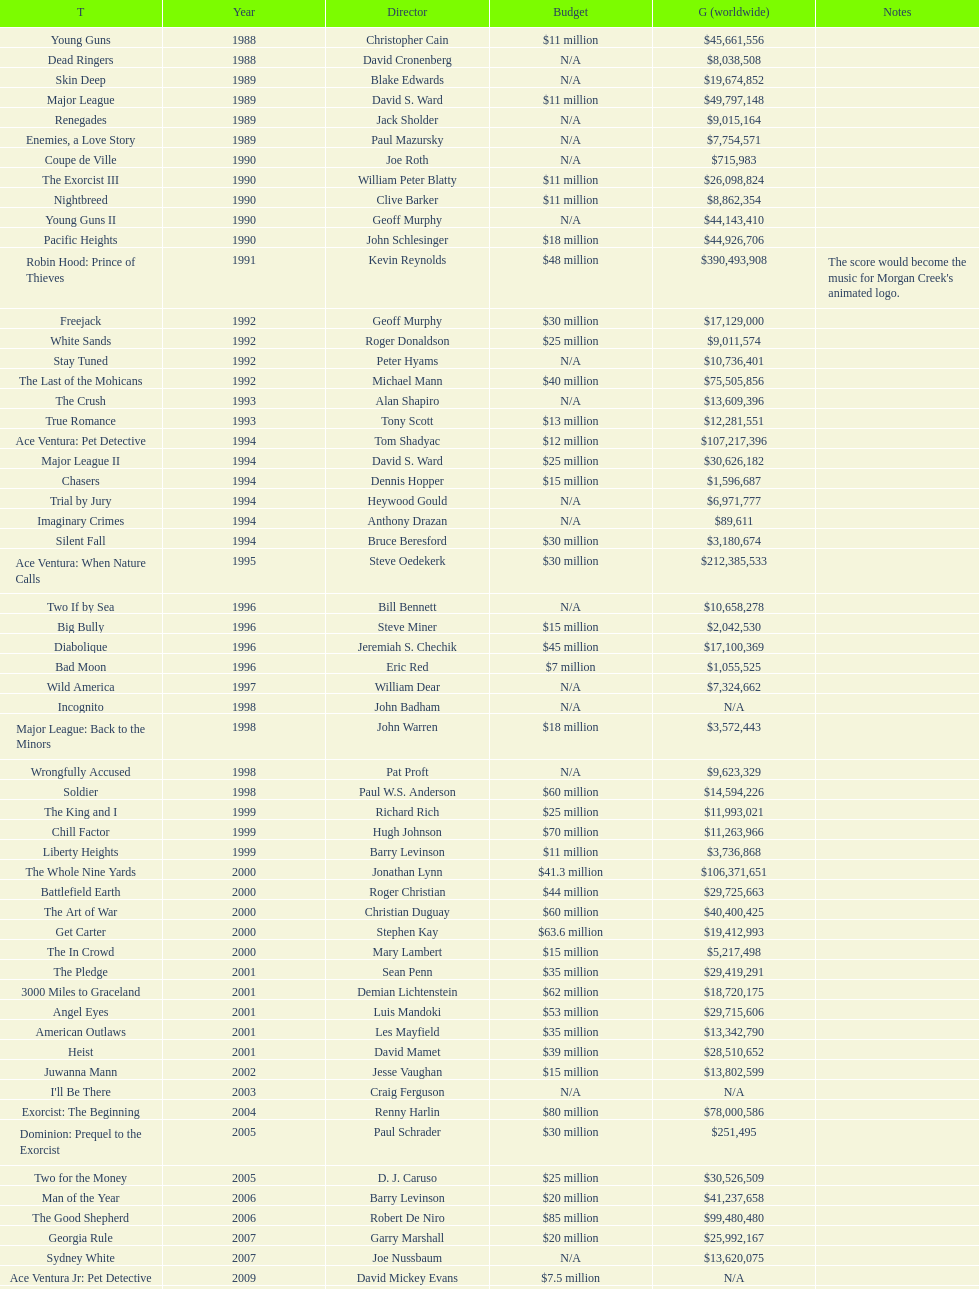How many films were there in 1990? 5. 